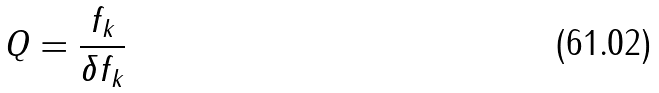<formula> <loc_0><loc_0><loc_500><loc_500>Q = \frac { f _ { k } } { \delta f _ { k } }</formula> 